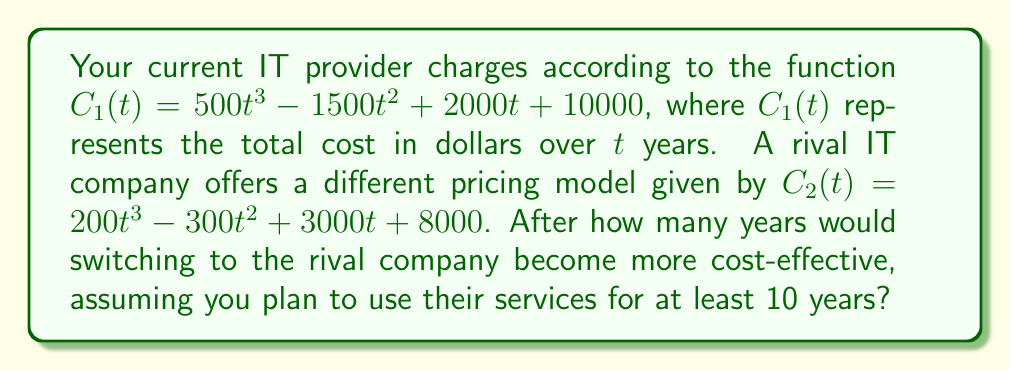Can you answer this question? To determine when switching becomes more cost-effective, we need to find the point where the cost of the rival company becomes less than the current provider. This occurs when $C_2(t) < C_1(t)$.

1) Set up the inequality:
   $200t^3 - 300t^2 + 3000t + 8000 < 500t^3 - 1500t^2 + 2000t + 10000$

2) Rearrange terms:
   $500t^3 - 1500t^2 + 2000t + 10000 - (200t^3 - 300t^2 + 3000t + 8000) > 0$
   $300t^3 - 1200t^2 - 1000t + 2000 > 0$

3) This is a cubic inequality. To solve it, we need to find the roots of the corresponding equation:
   $300t^3 - 1200t^2 - 1000t + 2000 = 0$

4) This equation is difficult to solve by factoring. Using a graphing calculator or computer algebra system, we find that the equation has three real roots: approximately 0.59, 1.33, and 3.41.

5) Analyzing the inequality:
   - For $t < 0.59$, the expression is positive
   - For $0.59 < t < 1.33$, the expression is negative
   - For $1.33 < t < 3.41$, the expression is positive
   - For $t > 3.41$, the expression is negative

6) Since we're looking for the point after which the rival company becomes more cost-effective, and we're planning to use the services for at least 10 years, we're interested in the last interval where the expression is negative, i.e., $t > 3.41$.

7) Rounding up to the nearest whole year (since we can't switch in the middle of a year), we get 4 years.

Therefore, switching to the rival company becomes more cost-effective after 4 years.
Answer: 4 years 